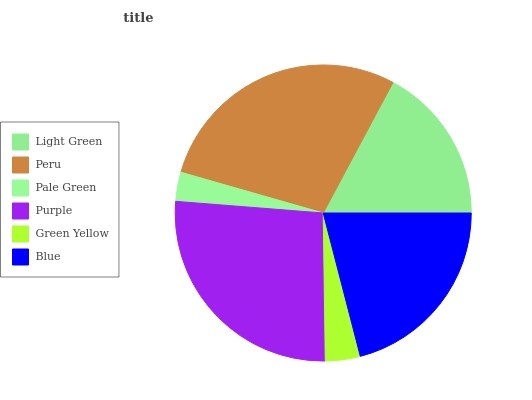Is Pale Green the minimum?
Answer yes or no. Yes. Is Peru the maximum?
Answer yes or no. Yes. Is Peru the minimum?
Answer yes or no. No. Is Pale Green the maximum?
Answer yes or no. No. Is Peru greater than Pale Green?
Answer yes or no. Yes. Is Pale Green less than Peru?
Answer yes or no. Yes. Is Pale Green greater than Peru?
Answer yes or no. No. Is Peru less than Pale Green?
Answer yes or no. No. Is Blue the high median?
Answer yes or no. Yes. Is Light Green the low median?
Answer yes or no. Yes. Is Peru the high median?
Answer yes or no. No. Is Pale Green the low median?
Answer yes or no. No. 